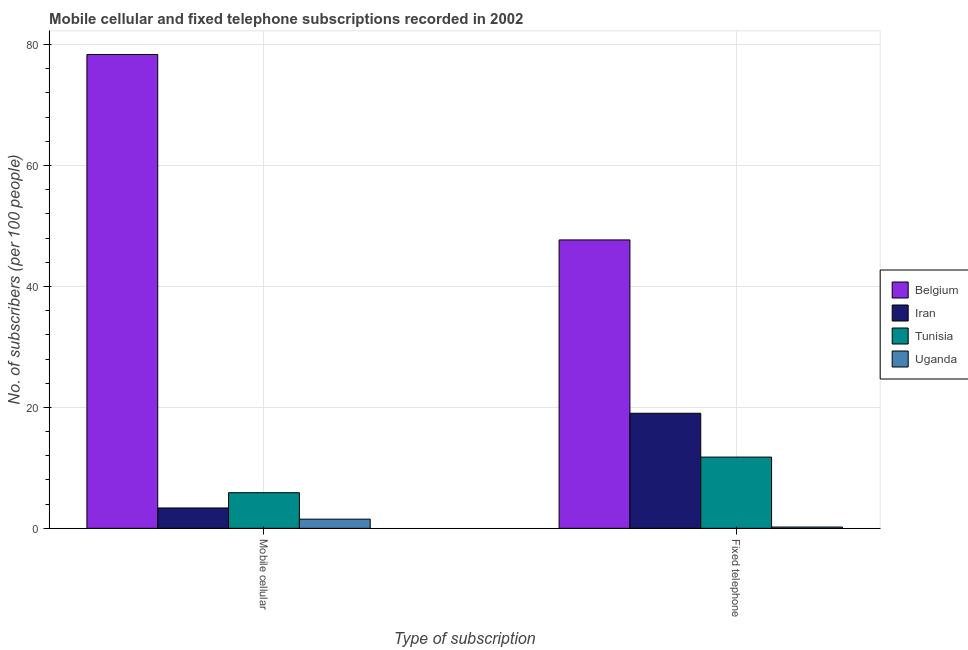How many different coloured bars are there?
Ensure brevity in your answer.  4. What is the label of the 2nd group of bars from the left?
Offer a very short reply. Fixed telephone. What is the number of fixed telephone subscribers in Tunisia?
Provide a succinct answer. 11.78. Across all countries, what is the maximum number of fixed telephone subscribers?
Your response must be concise. 47.7. Across all countries, what is the minimum number of mobile cellular subscribers?
Offer a terse response. 1.52. In which country was the number of fixed telephone subscribers maximum?
Make the answer very short. Belgium. In which country was the number of fixed telephone subscribers minimum?
Your answer should be compact. Uganda. What is the total number of mobile cellular subscribers in the graph?
Offer a terse response. 89.13. What is the difference between the number of fixed telephone subscribers in Uganda and that in Iran?
Ensure brevity in your answer.  -18.82. What is the difference between the number of mobile cellular subscribers in Uganda and the number of fixed telephone subscribers in Iran?
Offer a very short reply. -17.51. What is the average number of fixed telephone subscribers per country?
Offer a terse response. 19.68. What is the difference between the number of mobile cellular subscribers and number of fixed telephone subscribers in Uganda?
Ensure brevity in your answer.  1.3. In how many countries, is the number of fixed telephone subscribers greater than 44 ?
Offer a terse response. 1. What is the ratio of the number of mobile cellular subscribers in Uganda to that in Tunisia?
Provide a short and direct response. 0.26. Is the number of fixed telephone subscribers in Iran less than that in Tunisia?
Keep it short and to the point. No. In how many countries, is the number of fixed telephone subscribers greater than the average number of fixed telephone subscribers taken over all countries?
Make the answer very short. 1. What does the 2nd bar from the left in Mobile cellular represents?
Ensure brevity in your answer.  Iran. What does the 1st bar from the right in Fixed telephone represents?
Give a very brief answer. Uganda. How many bars are there?
Make the answer very short. 8. How many countries are there in the graph?
Offer a very short reply. 4. Are the values on the major ticks of Y-axis written in scientific E-notation?
Make the answer very short. No. What is the title of the graph?
Make the answer very short. Mobile cellular and fixed telephone subscriptions recorded in 2002. Does "Turkey" appear as one of the legend labels in the graph?
Give a very brief answer. No. What is the label or title of the X-axis?
Provide a succinct answer. Type of subscription. What is the label or title of the Y-axis?
Your answer should be very brief. No. of subscribers (per 100 people). What is the No. of subscribers (per 100 people) of Belgium in Mobile cellular?
Provide a short and direct response. 78.36. What is the No. of subscribers (per 100 people) of Iran in Mobile cellular?
Your answer should be compact. 3.37. What is the No. of subscribers (per 100 people) of Tunisia in Mobile cellular?
Your answer should be compact. 5.89. What is the No. of subscribers (per 100 people) in Uganda in Mobile cellular?
Provide a succinct answer. 1.52. What is the No. of subscribers (per 100 people) in Belgium in Fixed telephone?
Offer a terse response. 47.7. What is the No. of subscribers (per 100 people) in Iran in Fixed telephone?
Your response must be concise. 19.03. What is the No. of subscribers (per 100 people) of Tunisia in Fixed telephone?
Your answer should be very brief. 11.78. What is the No. of subscribers (per 100 people) in Uganda in Fixed telephone?
Make the answer very short. 0.21. Across all Type of subscription, what is the maximum No. of subscribers (per 100 people) in Belgium?
Make the answer very short. 78.36. Across all Type of subscription, what is the maximum No. of subscribers (per 100 people) of Iran?
Keep it short and to the point. 19.03. Across all Type of subscription, what is the maximum No. of subscribers (per 100 people) in Tunisia?
Offer a terse response. 11.78. Across all Type of subscription, what is the maximum No. of subscribers (per 100 people) in Uganda?
Your answer should be very brief. 1.52. Across all Type of subscription, what is the minimum No. of subscribers (per 100 people) of Belgium?
Ensure brevity in your answer.  47.7. Across all Type of subscription, what is the minimum No. of subscribers (per 100 people) in Iran?
Offer a terse response. 3.37. Across all Type of subscription, what is the minimum No. of subscribers (per 100 people) in Tunisia?
Your response must be concise. 5.89. Across all Type of subscription, what is the minimum No. of subscribers (per 100 people) of Uganda?
Your answer should be very brief. 0.21. What is the total No. of subscribers (per 100 people) in Belgium in the graph?
Offer a very short reply. 126.06. What is the total No. of subscribers (per 100 people) in Iran in the graph?
Your answer should be very brief. 22.39. What is the total No. of subscribers (per 100 people) in Tunisia in the graph?
Keep it short and to the point. 17.67. What is the total No. of subscribers (per 100 people) in Uganda in the graph?
Your response must be concise. 1.73. What is the difference between the No. of subscribers (per 100 people) of Belgium in Mobile cellular and that in Fixed telephone?
Your answer should be compact. 30.66. What is the difference between the No. of subscribers (per 100 people) of Iran in Mobile cellular and that in Fixed telephone?
Provide a succinct answer. -15.66. What is the difference between the No. of subscribers (per 100 people) of Tunisia in Mobile cellular and that in Fixed telephone?
Your response must be concise. -5.89. What is the difference between the No. of subscribers (per 100 people) in Uganda in Mobile cellular and that in Fixed telephone?
Your response must be concise. 1.3. What is the difference between the No. of subscribers (per 100 people) of Belgium in Mobile cellular and the No. of subscribers (per 100 people) of Iran in Fixed telephone?
Your response must be concise. 59.33. What is the difference between the No. of subscribers (per 100 people) in Belgium in Mobile cellular and the No. of subscribers (per 100 people) in Tunisia in Fixed telephone?
Provide a succinct answer. 66.58. What is the difference between the No. of subscribers (per 100 people) in Belgium in Mobile cellular and the No. of subscribers (per 100 people) in Uganda in Fixed telephone?
Offer a terse response. 78.15. What is the difference between the No. of subscribers (per 100 people) of Iran in Mobile cellular and the No. of subscribers (per 100 people) of Tunisia in Fixed telephone?
Your response must be concise. -8.42. What is the difference between the No. of subscribers (per 100 people) in Iran in Mobile cellular and the No. of subscribers (per 100 people) in Uganda in Fixed telephone?
Ensure brevity in your answer.  3.15. What is the difference between the No. of subscribers (per 100 people) in Tunisia in Mobile cellular and the No. of subscribers (per 100 people) in Uganda in Fixed telephone?
Provide a succinct answer. 5.68. What is the average No. of subscribers (per 100 people) in Belgium per Type of subscription?
Your answer should be very brief. 63.03. What is the average No. of subscribers (per 100 people) in Iran per Type of subscription?
Make the answer very short. 11.2. What is the average No. of subscribers (per 100 people) of Tunisia per Type of subscription?
Give a very brief answer. 8.84. What is the average No. of subscribers (per 100 people) of Uganda per Type of subscription?
Provide a succinct answer. 0.86. What is the difference between the No. of subscribers (per 100 people) of Belgium and No. of subscribers (per 100 people) of Iran in Mobile cellular?
Your answer should be compact. 75. What is the difference between the No. of subscribers (per 100 people) in Belgium and No. of subscribers (per 100 people) in Tunisia in Mobile cellular?
Give a very brief answer. 72.47. What is the difference between the No. of subscribers (per 100 people) of Belgium and No. of subscribers (per 100 people) of Uganda in Mobile cellular?
Offer a very short reply. 76.85. What is the difference between the No. of subscribers (per 100 people) of Iran and No. of subscribers (per 100 people) of Tunisia in Mobile cellular?
Ensure brevity in your answer.  -2.53. What is the difference between the No. of subscribers (per 100 people) in Iran and No. of subscribers (per 100 people) in Uganda in Mobile cellular?
Provide a short and direct response. 1.85. What is the difference between the No. of subscribers (per 100 people) of Tunisia and No. of subscribers (per 100 people) of Uganda in Mobile cellular?
Provide a short and direct response. 4.37. What is the difference between the No. of subscribers (per 100 people) of Belgium and No. of subscribers (per 100 people) of Iran in Fixed telephone?
Provide a succinct answer. 28.67. What is the difference between the No. of subscribers (per 100 people) of Belgium and No. of subscribers (per 100 people) of Tunisia in Fixed telephone?
Make the answer very short. 35.92. What is the difference between the No. of subscribers (per 100 people) in Belgium and No. of subscribers (per 100 people) in Uganda in Fixed telephone?
Offer a terse response. 47.49. What is the difference between the No. of subscribers (per 100 people) in Iran and No. of subscribers (per 100 people) in Tunisia in Fixed telephone?
Provide a succinct answer. 7.25. What is the difference between the No. of subscribers (per 100 people) of Iran and No. of subscribers (per 100 people) of Uganda in Fixed telephone?
Your answer should be compact. 18.82. What is the difference between the No. of subscribers (per 100 people) of Tunisia and No. of subscribers (per 100 people) of Uganda in Fixed telephone?
Provide a succinct answer. 11.57. What is the ratio of the No. of subscribers (per 100 people) of Belgium in Mobile cellular to that in Fixed telephone?
Keep it short and to the point. 1.64. What is the ratio of the No. of subscribers (per 100 people) in Iran in Mobile cellular to that in Fixed telephone?
Provide a succinct answer. 0.18. What is the ratio of the No. of subscribers (per 100 people) of Tunisia in Mobile cellular to that in Fixed telephone?
Offer a terse response. 0.5. What is the ratio of the No. of subscribers (per 100 people) of Uganda in Mobile cellular to that in Fixed telephone?
Provide a succinct answer. 7.15. What is the difference between the highest and the second highest No. of subscribers (per 100 people) in Belgium?
Your answer should be compact. 30.66. What is the difference between the highest and the second highest No. of subscribers (per 100 people) of Iran?
Keep it short and to the point. 15.66. What is the difference between the highest and the second highest No. of subscribers (per 100 people) in Tunisia?
Your response must be concise. 5.89. What is the difference between the highest and the second highest No. of subscribers (per 100 people) in Uganda?
Your response must be concise. 1.3. What is the difference between the highest and the lowest No. of subscribers (per 100 people) of Belgium?
Provide a succinct answer. 30.66. What is the difference between the highest and the lowest No. of subscribers (per 100 people) in Iran?
Give a very brief answer. 15.66. What is the difference between the highest and the lowest No. of subscribers (per 100 people) of Tunisia?
Provide a short and direct response. 5.89. What is the difference between the highest and the lowest No. of subscribers (per 100 people) of Uganda?
Ensure brevity in your answer.  1.3. 